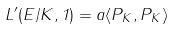Convert formula to latex. <formula><loc_0><loc_0><loc_500><loc_500>L ^ { \prime } ( E / K , 1 ) = a \langle P _ { K } , P _ { K } \rangle</formula> 